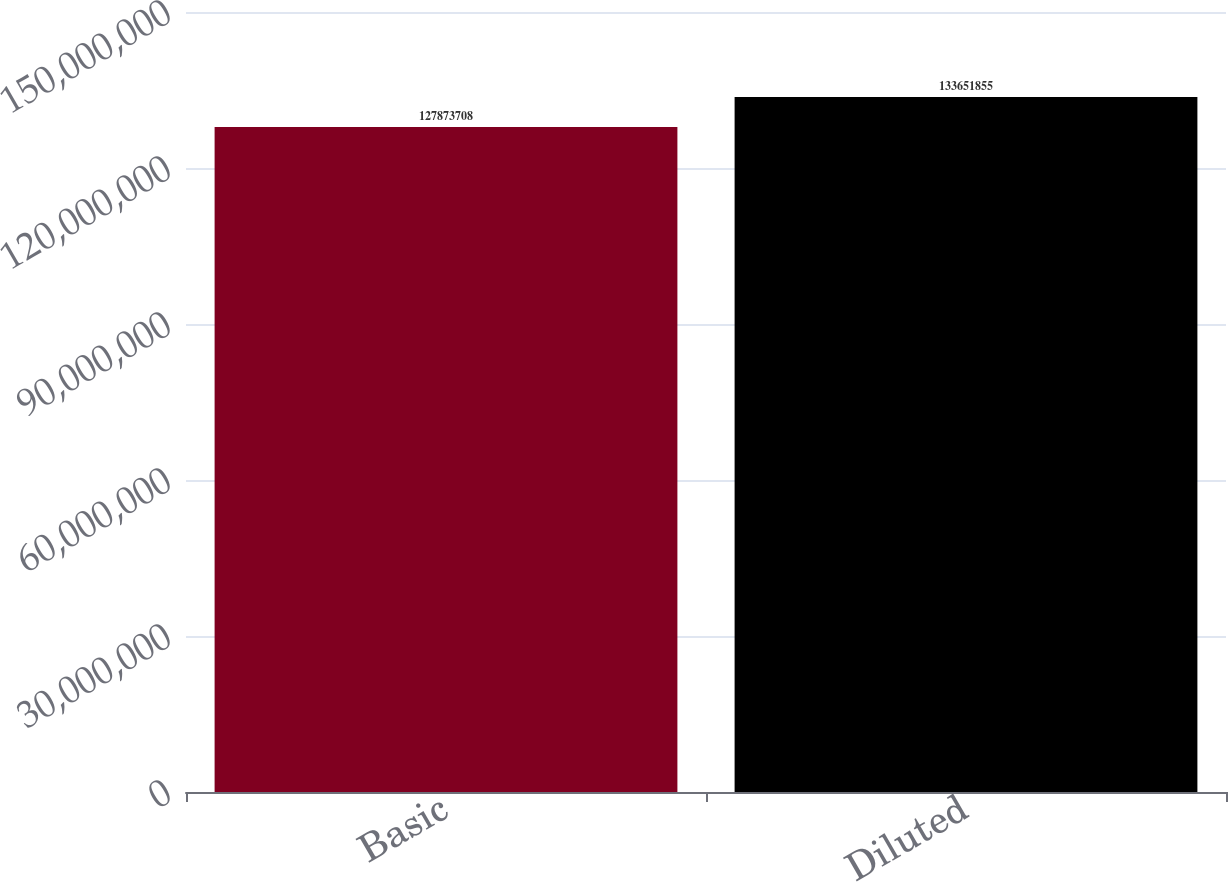Convert chart to OTSL. <chart><loc_0><loc_0><loc_500><loc_500><bar_chart><fcel>Basic<fcel>Diluted<nl><fcel>1.27874e+08<fcel>1.33652e+08<nl></chart> 